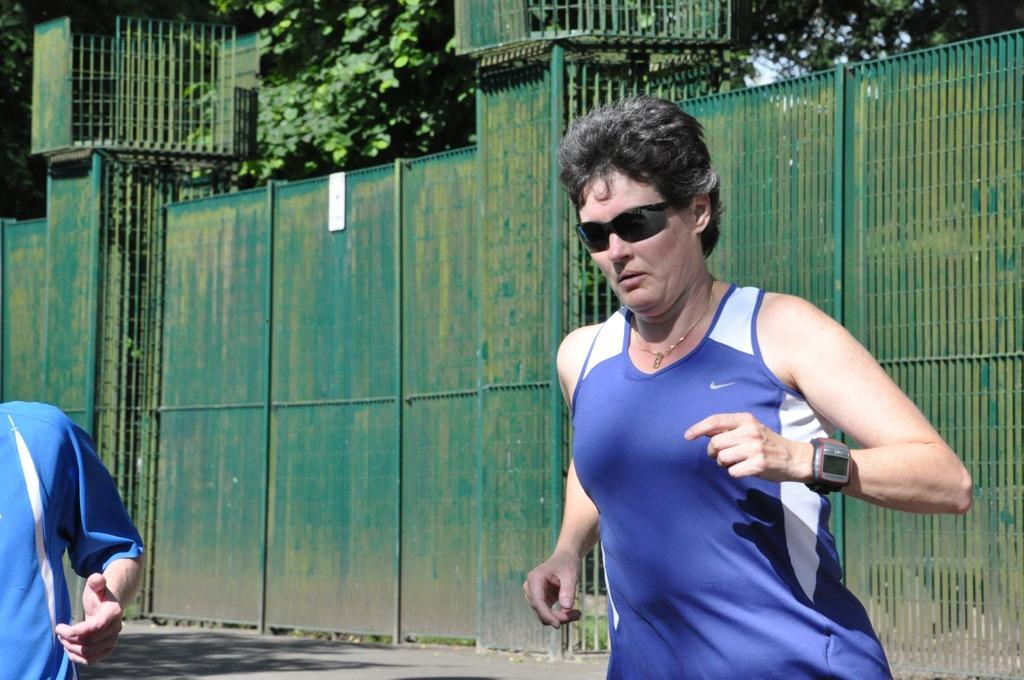Who is the main subject in the image? There is a lady in the image. What is the lady wearing on her face? The lady is wearing goggles. What accessory is the lady wearing on her wrist? The lady is wearing a watch. Can you describe the other person in the image? There is another person in the image, but no specific details are provided about them. What can be seen in the background of the image? There is a fencing and trees in the background of the image. What type of cherries can be seen hanging from the lady's ears in the image? There are no cherries present in the image, nor are they hanging from the lady's ears. 